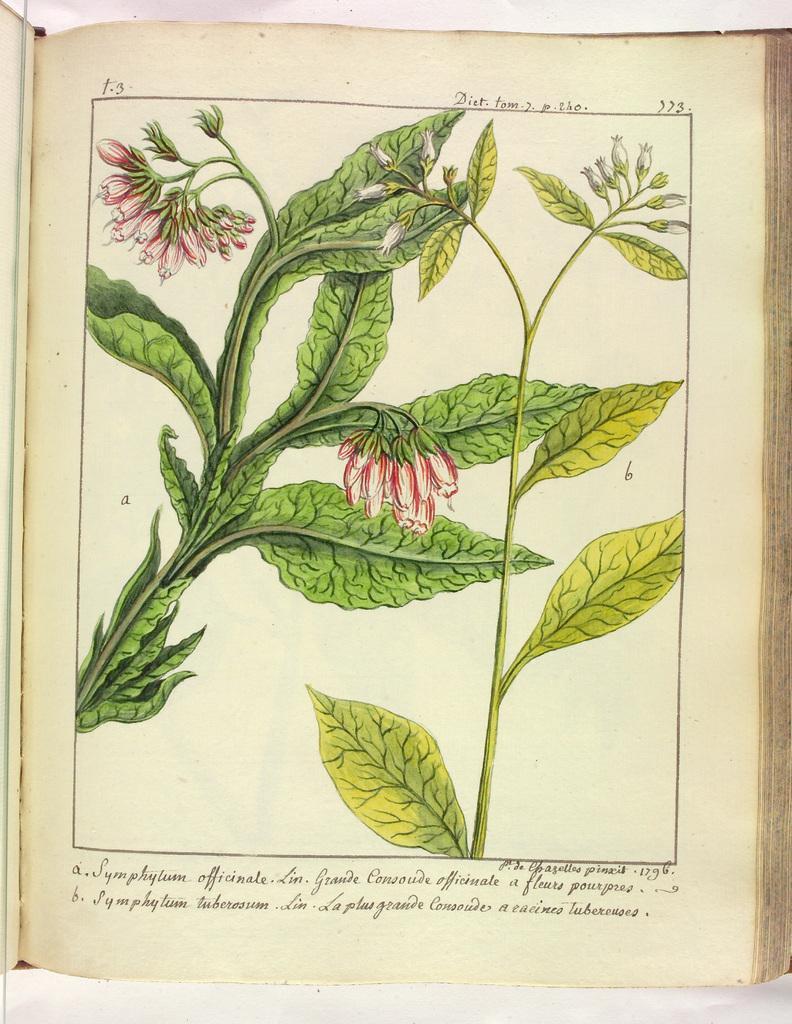Could you give a brief overview of what you see in this image? In this picture we can see a book of a page, where we can see leaves, flowers and some text on it. 